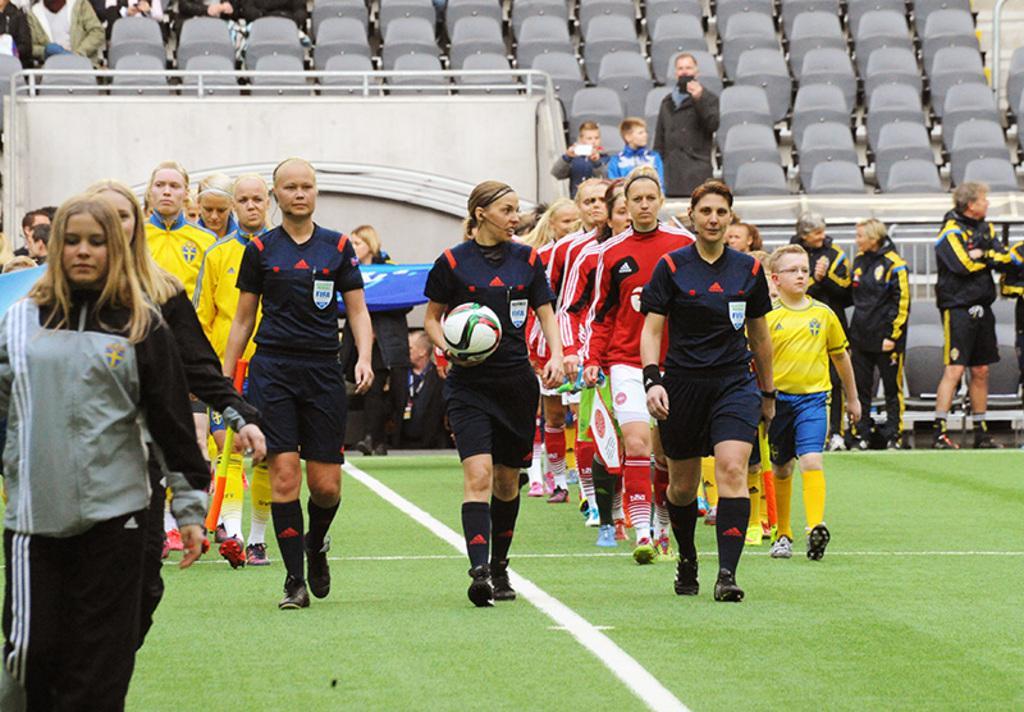In one or two sentences, can you explain what this image depicts? In this picture there are two rows of people walking in a line. Before them there are three people in blue dress, walking before them. A woman in the middle is holding a ball. To the left side there is a woman wearing grey t shirt and black trousers. In the background there are some people and empty seats. 